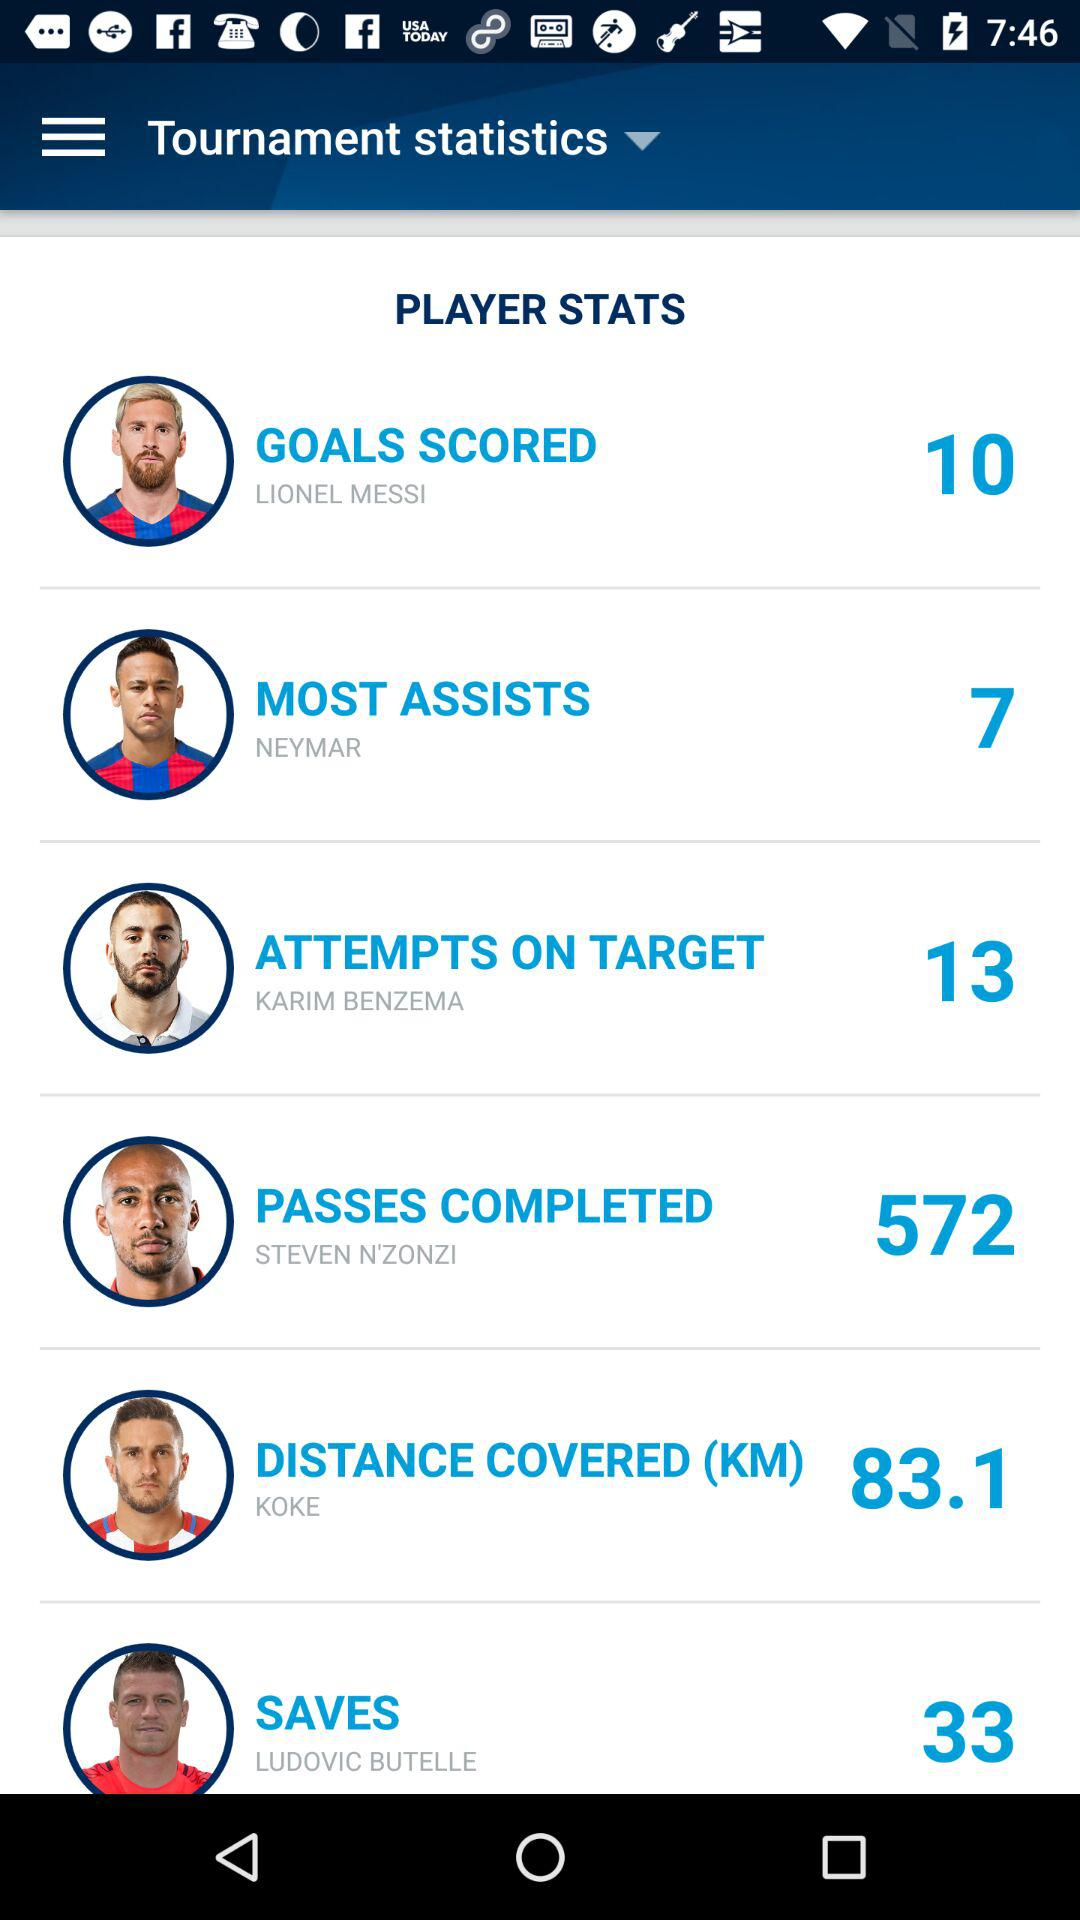How many goals has Lionel Messi scored? Lionel Messi has scored 10 goals. 